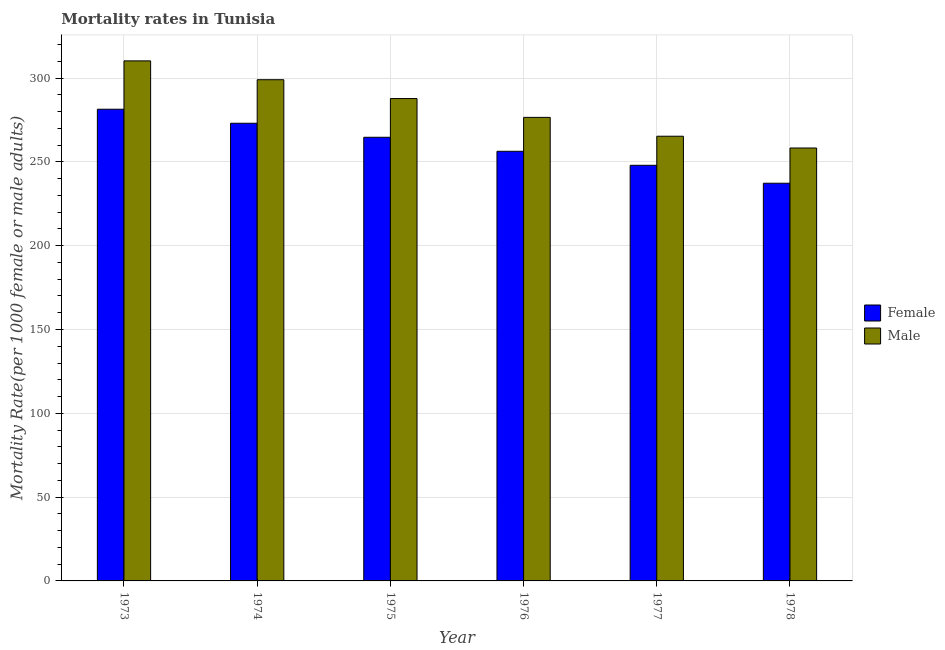Are the number of bars on each tick of the X-axis equal?
Offer a terse response. Yes. How many bars are there on the 5th tick from the left?
Offer a very short reply. 2. How many bars are there on the 3rd tick from the right?
Offer a terse response. 2. What is the label of the 6th group of bars from the left?
Your response must be concise. 1978. In how many cases, is the number of bars for a given year not equal to the number of legend labels?
Give a very brief answer. 0. What is the male mortality rate in 1977?
Give a very brief answer. 265.31. Across all years, what is the maximum female mortality rate?
Keep it short and to the point. 281.42. Across all years, what is the minimum male mortality rate?
Provide a short and direct response. 258.28. In which year was the male mortality rate maximum?
Make the answer very short. 1973. In which year was the female mortality rate minimum?
Keep it short and to the point. 1978. What is the total female mortality rate in the graph?
Keep it short and to the point. 1560.72. What is the difference between the female mortality rate in 1974 and that in 1975?
Keep it short and to the point. 8.37. What is the difference between the female mortality rate in 1975 and the male mortality rate in 1973?
Your answer should be very brief. -16.73. What is the average male mortality rate per year?
Your answer should be compact. 282.87. In the year 1973, what is the difference between the female mortality rate and male mortality rate?
Provide a short and direct response. 0. In how many years, is the female mortality rate greater than 180?
Your response must be concise. 6. What is the ratio of the female mortality rate in 1973 to that in 1975?
Your answer should be compact. 1.06. Is the female mortality rate in 1975 less than that in 1978?
Provide a succinct answer. No. What is the difference between the highest and the second highest female mortality rate?
Your answer should be compact. 8.37. What is the difference between the highest and the lowest male mortality rate?
Your answer should be very brief. 51.98. In how many years, is the female mortality rate greater than the average female mortality rate taken over all years?
Your response must be concise. 3. What is the difference between two consecutive major ticks on the Y-axis?
Give a very brief answer. 50. How many legend labels are there?
Your response must be concise. 2. How are the legend labels stacked?
Keep it short and to the point. Vertical. What is the title of the graph?
Your response must be concise. Mortality rates in Tunisia. Does "Quality of trade" appear as one of the legend labels in the graph?
Give a very brief answer. No. What is the label or title of the X-axis?
Ensure brevity in your answer.  Year. What is the label or title of the Y-axis?
Ensure brevity in your answer.  Mortality Rate(per 1000 female or male adults). What is the Mortality Rate(per 1000 female or male adults) in Female in 1973?
Your answer should be compact. 281.42. What is the Mortality Rate(per 1000 female or male adults) of Male in 1973?
Your response must be concise. 310.27. What is the Mortality Rate(per 1000 female or male adults) in Female in 1974?
Your answer should be very brief. 273.06. What is the Mortality Rate(per 1000 female or male adults) of Male in 1974?
Your answer should be very brief. 299.03. What is the Mortality Rate(per 1000 female or male adults) of Female in 1975?
Your answer should be very brief. 264.69. What is the Mortality Rate(per 1000 female or male adults) in Male in 1975?
Keep it short and to the point. 287.79. What is the Mortality Rate(per 1000 female or male adults) of Female in 1976?
Keep it short and to the point. 256.32. What is the Mortality Rate(per 1000 female or male adults) in Male in 1976?
Provide a succinct answer. 276.55. What is the Mortality Rate(per 1000 female or male adults) of Female in 1977?
Offer a terse response. 247.96. What is the Mortality Rate(per 1000 female or male adults) in Male in 1977?
Your response must be concise. 265.31. What is the Mortality Rate(per 1000 female or male adults) in Female in 1978?
Provide a succinct answer. 237.27. What is the Mortality Rate(per 1000 female or male adults) of Male in 1978?
Offer a very short reply. 258.28. Across all years, what is the maximum Mortality Rate(per 1000 female or male adults) of Female?
Ensure brevity in your answer.  281.42. Across all years, what is the maximum Mortality Rate(per 1000 female or male adults) of Male?
Make the answer very short. 310.27. Across all years, what is the minimum Mortality Rate(per 1000 female or male adults) of Female?
Ensure brevity in your answer.  237.27. Across all years, what is the minimum Mortality Rate(per 1000 female or male adults) in Male?
Your answer should be compact. 258.28. What is the total Mortality Rate(per 1000 female or male adults) in Female in the graph?
Make the answer very short. 1560.72. What is the total Mortality Rate(per 1000 female or male adults) in Male in the graph?
Provide a succinct answer. 1697.23. What is the difference between the Mortality Rate(per 1000 female or male adults) of Female in 1973 and that in 1974?
Keep it short and to the point. 8.37. What is the difference between the Mortality Rate(per 1000 female or male adults) of Male in 1973 and that in 1974?
Ensure brevity in your answer.  11.24. What is the difference between the Mortality Rate(per 1000 female or male adults) in Female in 1973 and that in 1975?
Give a very brief answer. 16.73. What is the difference between the Mortality Rate(per 1000 female or male adults) in Male in 1973 and that in 1975?
Give a very brief answer. 22.48. What is the difference between the Mortality Rate(per 1000 female or male adults) in Female in 1973 and that in 1976?
Provide a short and direct response. 25.1. What is the difference between the Mortality Rate(per 1000 female or male adults) of Male in 1973 and that in 1976?
Provide a succinct answer. 33.72. What is the difference between the Mortality Rate(per 1000 female or male adults) of Female in 1973 and that in 1977?
Give a very brief answer. 33.46. What is the difference between the Mortality Rate(per 1000 female or male adults) of Male in 1973 and that in 1977?
Offer a terse response. 44.95. What is the difference between the Mortality Rate(per 1000 female or male adults) of Female in 1973 and that in 1978?
Ensure brevity in your answer.  44.16. What is the difference between the Mortality Rate(per 1000 female or male adults) of Male in 1973 and that in 1978?
Offer a terse response. 51.98. What is the difference between the Mortality Rate(per 1000 female or male adults) of Female in 1974 and that in 1975?
Your answer should be compact. 8.37. What is the difference between the Mortality Rate(per 1000 female or male adults) of Male in 1974 and that in 1975?
Offer a terse response. 11.24. What is the difference between the Mortality Rate(per 1000 female or male adults) in Female in 1974 and that in 1976?
Your answer should be very brief. 16.73. What is the difference between the Mortality Rate(per 1000 female or male adults) of Male in 1974 and that in 1976?
Offer a terse response. 22.48. What is the difference between the Mortality Rate(per 1000 female or male adults) of Female in 1974 and that in 1977?
Provide a succinct answer. 25.1. What is the difference between the Mortality Rate(per 1000 female or male adults) in Male in 1974 and that in 1977?
Provide a short and direct response. 33.72. What is the difference between the Mortality Rate(per 1000 female or male adults) of Female in 1974 and that in 1978?
Provide a succinct answer. 35.79. What is the difference between the Mortality Rate(per 1000 female or male adults) in Male in 1974 and that in 1978?
Ensure brevity in your answer.  40.74. What is the difference between the Mortality Rate(per 1000 female or male adults) in Female in 1975 and that in 1976?
Provide a short and direct response. 8.37. What is the difference between the Mortality Rate(per 1000 female or male adults) of Male in 1975 and that in 1976?
Provide a succinct answer. 11.24. What is the difference between the Mortality Rate(per 1000 female or male adults) of Female in 1975 and that in 1977?
Your answer should be very brief. 16.73. What is the difference between the Mortality Rate(per 1000 female or male adults) of Male in 1975 and that in 1977?
Your answer should be very brief. 22.48. What is the difference between the Mortality Rate(per 1000 female or male adults) in Female in 1975 and that in 1978?
Your answer should be compact. 27.42. What is the difference between the Mortality Rate(per 1000 female or male adults) in Male in 1975 and that in 1978?
Make the answer very short. 29.5. What is the difference between the Mortality Rate(per 1000 female or male adults) in Female in 1976 and that in 1977?
Provide a short and direct response. 8.37. What is the difference between the Mortality Rate(per 1000 female or male adults) in Male in 1976 and that in 1977?
Offer a very short reply. 11.24. What is the difference between the Mortality Rate(per 1000 female or male adults) in Female in 1976 and that in 1978?
Provide a short and direct response. 19.06. What is the difference between the Mortality Rate(per 1000 female or male adults) in Male in 1976 and that in 1978?
Your answer should be very brief. 18.27. What is the difference between the Mortality Rate(per 1000 female or male adults) in Female in 1977 and that in 1978?
Offer a very short reply. 10.69. What is the difference between the Mortality Rate(per 1000 female or male adults) in Male in 1977 and that in 1978?
Give a very brief answer. 7.03. What is the difference between the Mortality Rate(per 1000 female or male adults) in Female in 1973 and the Mortality Rate(per 1000 female or male adults) in Male in 1974?
Your answer should be very brief. -17.6. What is the difference between the Mortality Rate(per 1000 female or male adults) of Female in 1973 and the Mortality Rate(per 1000 female or male adults) of Male in 1975?
Your answer should be very brief. -6.37. What is the difference between the Mortality Rate(per 1000 female or male adults) in Female in 1973 and the Mortality Rate(per 1000 female or male adults) in Male in 1976?
Offer a very short reply. 4.87. What is the difference between the Mortality Rate(per 1000 female or male adults) in Female in 1973 and the Mortality Rate(per 1000 female or male adults) in Male in 1977?
Give a very brief answer. 16.11. What is the difference between the Mortality Rate(per 1000 female or male adults) of Female in 1973 and the Mortality Rate(per 1000 female or male adults) of Male in 1978?
Your answer should be compact. 23.14. What is the difference between the Mortality Rate(per 1000 female or male adults) in Female in 1974 and the Mortality Rate(per 1000 female or male adults) in Male in 1975?
Make the answer very short. -14.73. What is the difference between the Mortality Rate(per 1000 female or male adults) in Female in 1974 and the Mortality Rate(per 1000 female or male adults) in Male in 1976?
Offer a terse response. -3.49. What is the difference between the Mortality Rate(per 1000 female or male adults) of Female in 1974 and the Mortality Rate(per 1000 female or male adults) of Male in 1977?
Make the answer very short. 7.75. What is the difference between the Mortality Rate(per 1000 female or male adults) in Female in 1974 and the Mortality Rate(per 1000 female or male adults) in Male in 1978?
Offer a very short reply. 14.77. What is the difference between the Mortality Rate(per 1000 female or male adults) in Female in 1975 and the Mortality Rate(per 1000 female or male adults) in Male in 1976?
Offer a very short reply. -11.86. What is the difference between the Mortality Rate(per 1000 female or male adults) in Female in 1975 and the Mortality Rate(per 1000 female or male adults) in Male in 1977?
Your response must be concise. -0.62. What is the difference between the Mortality Rate(per 1000 female or male adults) of Female in 1975 and the Mortality Rate(per 1000 female or male adults) of Male in 1978?
Your response must be concise. 6.41. What is the difference between the Mortality Rate(per 1000 female or male adults) in Female in 1976 and the Mortality Rate(per 1000 female or male adults) in Male in 1977?
Your answer should be compact. -8.99. What is the difference between the Mortality Rate(per 1000 female or male adults) of Female in 1976 and the Mortality Rate(per 1000 female or male adults) of Male in 1978?
Give a very brief answer. -1.96. What is the difference between the Mortality Rate(per 1000 female or male adults) in Female in 1977 and the Mortality Rate(per 1000 female or male adults) in Male in 1978?
Make the answer very short. -10.33. What is the average Mortality Rate(per 1000 female or male adults) in Female per year?
Provide a short and direct response. 260.12. What is the average Mortality Rate(per 1000 female or male adults) in Male per year?
Make the answer very short. 282.87. In the year 1973, what is the difference between the Mortality Rate(per 1000 female or male adults) in Female and Mortality Rate(per 1000 female or male adults) in Male?
Your answer should be very brief. -28.84. In the year 1974, what is the difference between the Mortality Rate(per 1000 female or male adults) of Female and Mortality Rate(per 1000 female or male adults) of Male?
Your answer should be compact. -25.97. In the year 1975, what is the difference between the Mortality Rate(per 1000 female or male adults) in Female and Mortality Rate(per 1000 female or male adults) in Male?
Ensure brevity in your answer.  -23.1. In the year 1976, what is the difference between the Mortality Rate(per 1000 female or male adults) of Female and Mortality Rate(per 1000 female or male adults) of Male?
Your response must be concise. -20.23. In the year 1977, what is the difference between the Mortality Rate(per 1000 female or male adults) in Female and Mortality Rate(per 1000 female or male adults) in Male?
Ensure brevity in your answer.  -17.35. In the year 1978, what is the difference between the Mortality Rate(per 1000 female or male adults) in Female and Mortality Rate(per 1000 female or male adults) in Male?
Ensure brevity in your answer.  -21.02. What is the ratio of the Mortality Rate(per 1000 female or male adults) in Female in 1973 to that in 1974?
Offer a very short reply. 1.03. What is the ratio of the Mortality Rate(per 1000 female or male adults) of Male in 1973 to that in 1974?
Make the answer very short. 1.04. What is the ratio of the Mortality Rate(per 1000 female or male adults) of Female in 1973 to that in 1975?
Your answer should be compact. 1.06. What is the ratio of the Mortality Rate(per 1000 female or male adults) of Male in 1973 to that in 1975?
Your answer should be very brief. 1.08. What is the ratio of the Mortality Rate(per 1000 female or male adults) in Female in 1973 to that in 1976?
Your response must be concise. 1.1. What is the ratio of the Mortality Rate(per 1000 female or male adults) of Male in 1973 to that in 1976?
Provide a short and direct response. 1.12. What is the ratio of the Mortality Rate(per 1000 female or male adults) in Female in 1973 to that in 1977?
Your answer should be compact. 1.14. What is the ratio of the Mortality Rate(per 1000 female or male adults) in Male in 1973 to that in 1977?
Give a very brief answer. 1.17. What is the ratio of the Mortality Rate(per 1000 female or male adults) in Female in 1973 to that in 1978?
Provide a short and direct response. 1.19. What is the ratio of the Mortality Rate(per 1000 female or male adults) of Male in 1973 to that in 1978?
Offer a very short reply. 1.2. What is the ratio of the Mortality Rate(per 1000 female or male adults) in Female in 1974 to that in 1975?
Ensure brevity in your answer.  1.03. What is the ratio of the Mortality Rate(per 1000 female or male adults) in Male in 1974 to that in 1975?
Ensure brevity in your answer.  1.04. What is the ratio of the Mortality Rate(per 1000 female or male adults) of Female in 1974 to that in 1976?
Your answer should be very brief. 1.07. What is the ratio of the Mortality Rate(per 1000 female or male adults) in Male in 1974 to that in 1976?
Provide a short and direct response. 1.08. What is the ratio of the Mortality Rate(per 1000 female or male adults) in Female in 1974 to that in 1977?
Provide a succinct answer. 1.1. What is the ratio of the Mortality Rate(per 1000 female or male adults) of Male in 1974 to that in 1977?
Offer a terse response. 1.13. What is the ratio of the Mortality Rate(per 1000 female or male adults) of Female in 1974 to that in 1978?
Your answer should be very brief. 1.15. What is the ratio of the Mortality Rate(per 1000 female or male adults) in Male in 1974 to that in 1978?
Ensure brevity in your answer.  1.16. What is the ratio of the Mortality Rate(per 1000 female or male adults) in Female in 1975 to that in 1976?
Your answer should be compact. 1.03. What is the ratio of the Mortality Rate(per 1000 female or male adults) of Male in 1975 to that in 1976?
Offer a terse response. 1.04. What is the ratio of the Mortality Rate(per 1000 female or male adults) in Female in 1975 to that in 1977?
Provide a succinct answer. 1.07. What is the ratio of the Mortality Rate(per 1000 female or male adults) of Male in 1975 to that in 1977?
Your response must be concise. 1.08. What is the ratio of the Mortality Rate(per 1000 female or male adults) of Female in 1975 to that in 1978?
Ensure brevity in your answer.  1.12. What is the ratio of the Mortality Rate(per 1000 female or male adults) of Male in 1975 to that in 1978?
Keep it short and to the point. 1.11. What is the ratio of the Mortality Rate(per 1000 female or male adults) of Female in 1976 to that in 1977?
Provide a succinct answer. 1.03. What is the ratio of the Mortality Rate(per 1000 female or male adults) of Male in 1976 to that in 1977?
Ensure brevity in your answer.  1.04. What is the ratio of the Mortality Rate(per 1000 female or male adults) of Female in 1976 to that in 1978?
Provide a succinct answer. 1.08. What is the ratio of the Mortality Rate(per 1000 female or male adults) in Male in 1976 to that in 1978?
Your answer should be very brief. 1.07. What is the ratio of the Mortality Rate(per 1000 female or male adults) of Female in 1977 to that in 1978?
Your answer should be very brief. 1.05. What is the ratio of the Mortality Rate(per 1000 female or male adults) in Male in 1977 to that in 1978?
Make the answer very short. 1.03. What is the difference between the highest and the second highest Mortality Rate(per 1000 female or male adults) in Female?
Your answer should be very brief. 8.37. What is the difference between the highest and the second highest Mortality Rate(per 1000 female or male adults) in Male?
Your answer should be very brief. 11.24. What is the difference between the highest and the lowest Mortality Rate(per 1000 female or male adults) of Female?
Your response must be concise. 44.16. What is the difference between the highest and the lowest Mortality Rate(per 1000 female or male adults) in Male?
Offer a terse response. 51.98. 